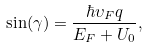<formula> <loc_0><loc_0><loc_500><loc_500>\sin ( \gamma ) = \frac { \hbar { \upsilon } _ { F } q } { E _ { F } + U _ { 0 } } ,</formula> 